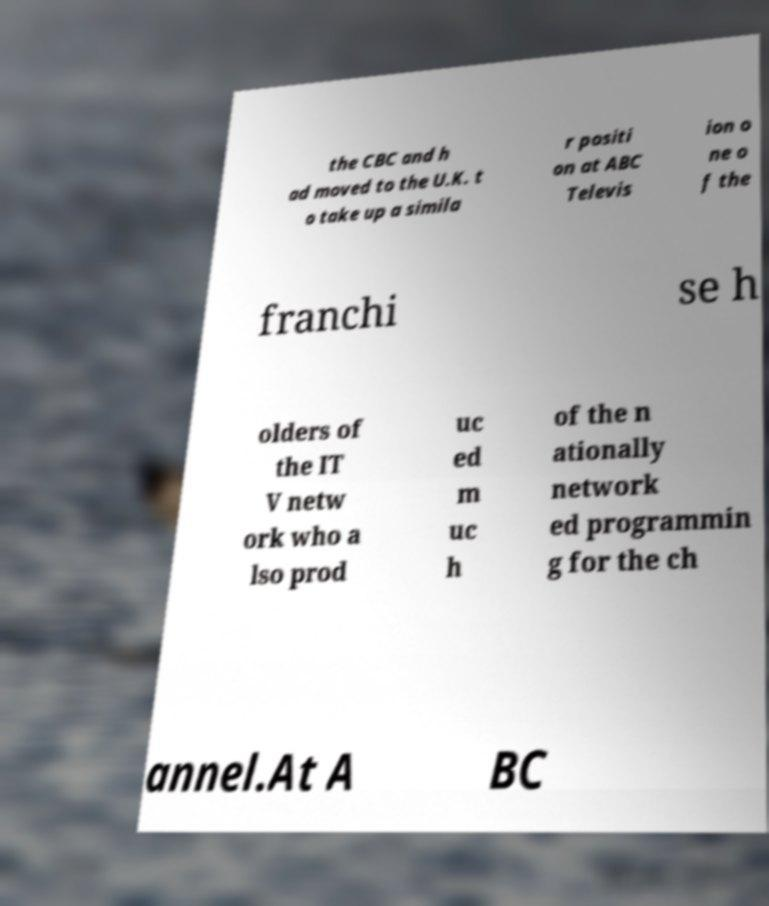Can you accurately transcribe the text from the provided image for me? the CBC and h ad moved to the U.K. t o take up a simila r positi on at ABC Televis ion o ne o f the franchi se h olders of the IT V netw ork who a lso prod uc ed m uc h of the n ationally network ed programmin g for the ch annel.At A BC 